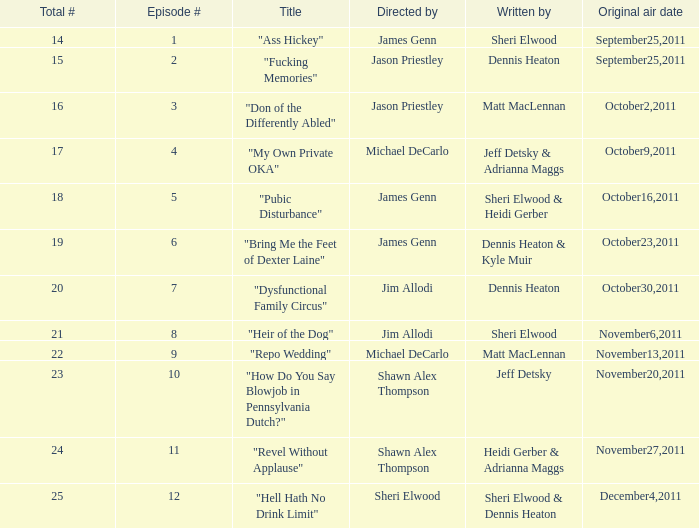How many different episode numbers does the episode written by Sheri Elwood and directed by Jim Allodi have? 1.0. 